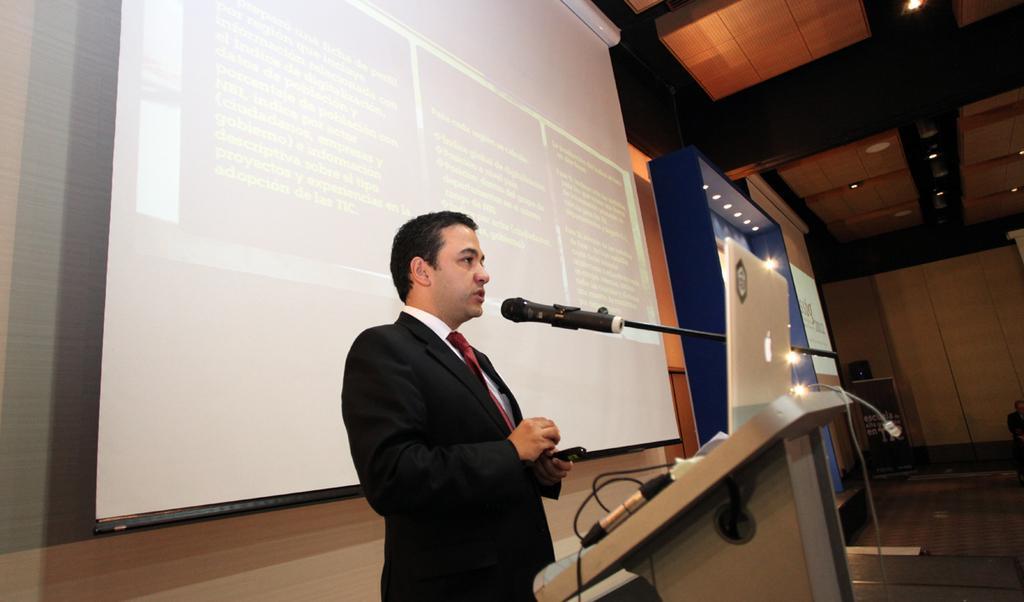In one or two sentences, can you explain what this image depicts? In the center of the image, we can see a man standing and holding an object in front of podium and we can see a laptop on it. In the background, there is a screen, mic with stand and dome lights. At the bottom, there is floor. 